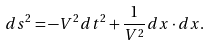Convert formula to latex. <formula><loc_0><loc_0><loc_500><loc_500>d s ^ { 2 } = - V ^ { 2 } d t ^ { 2 } + \frac { 1 } { V ^ { 2 } } d { x } \cdot d { x } .</formula> 